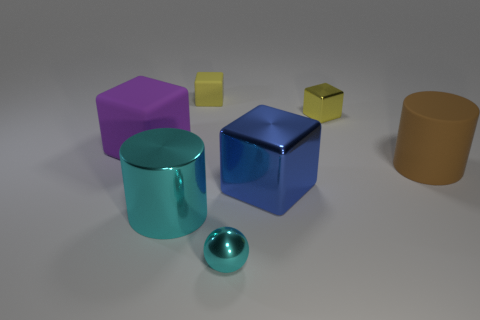Are there any other things that have the same color as the small metallic block? Yes, the small metallic block has a yellow color that appears similar to one of the faces of the smaller cube on the right. 